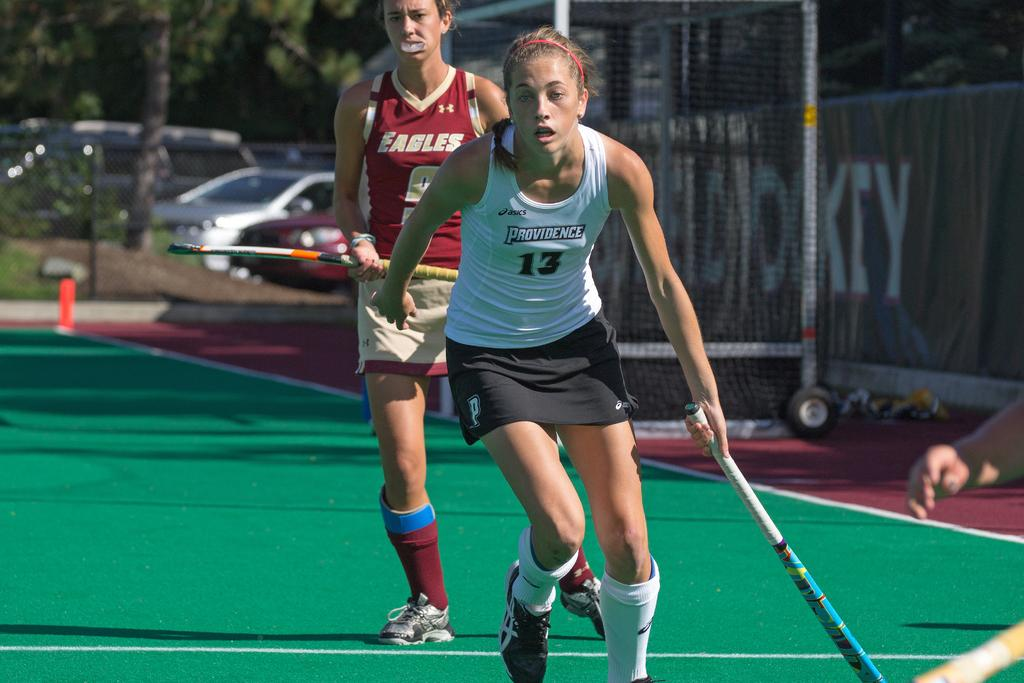<image>
Summarize the visual content of the image. A female Providence field hockey player runs in front of a girl in red Eagles uniform 